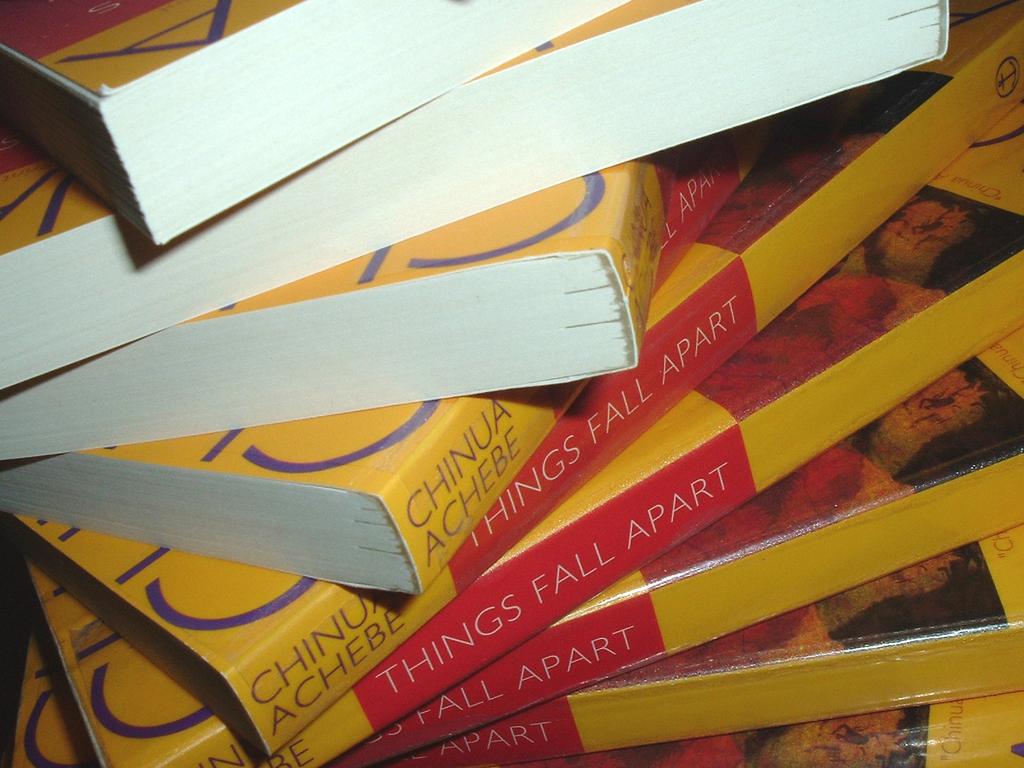Who authored "things fall apart"?
Make the answer very short. Chinua achebe. 